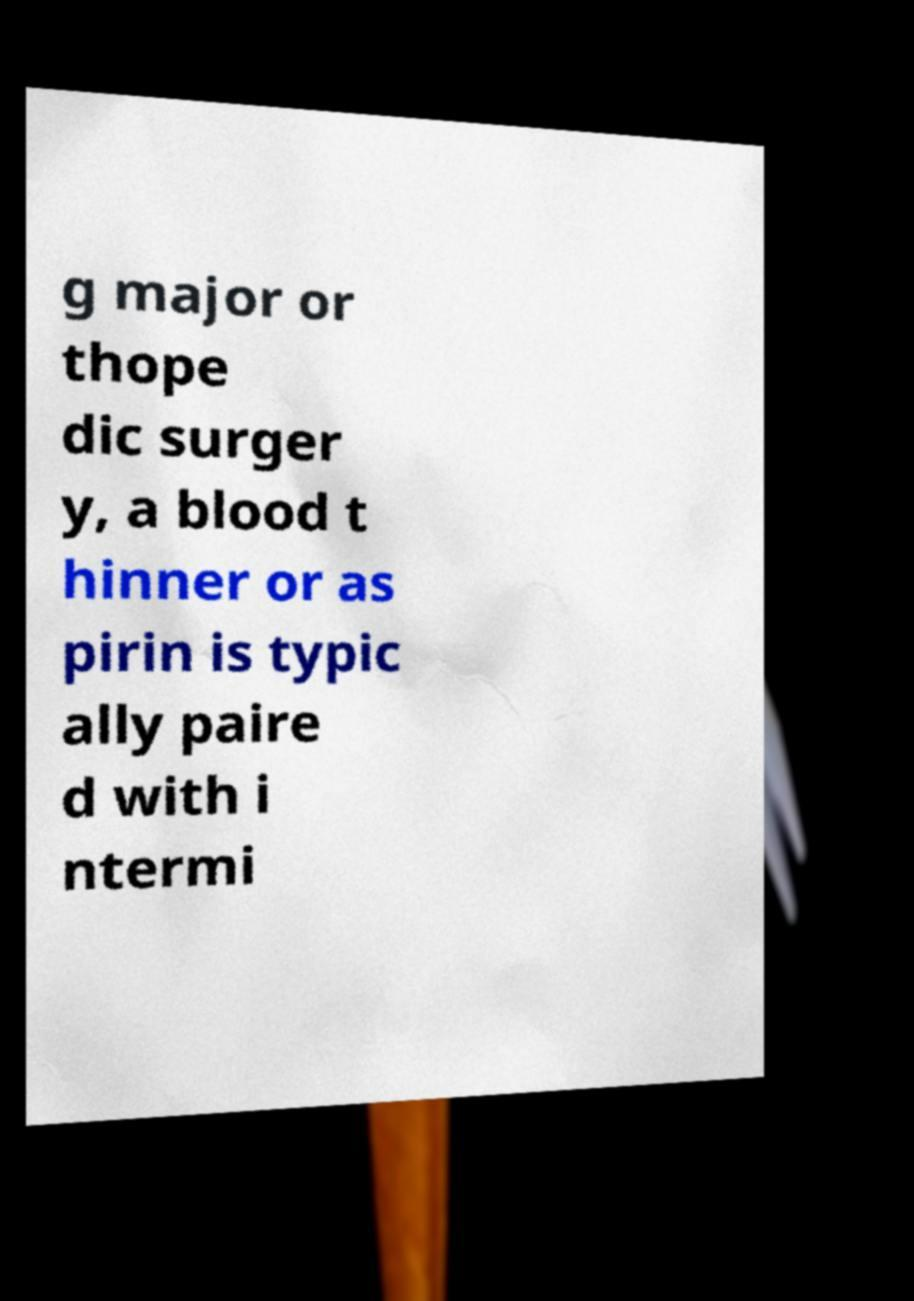Please identify and transcribe the text found in this image. g major or thope dic surger y, a blood t hinner or as pirin is typic ally paire d with i ntermi 